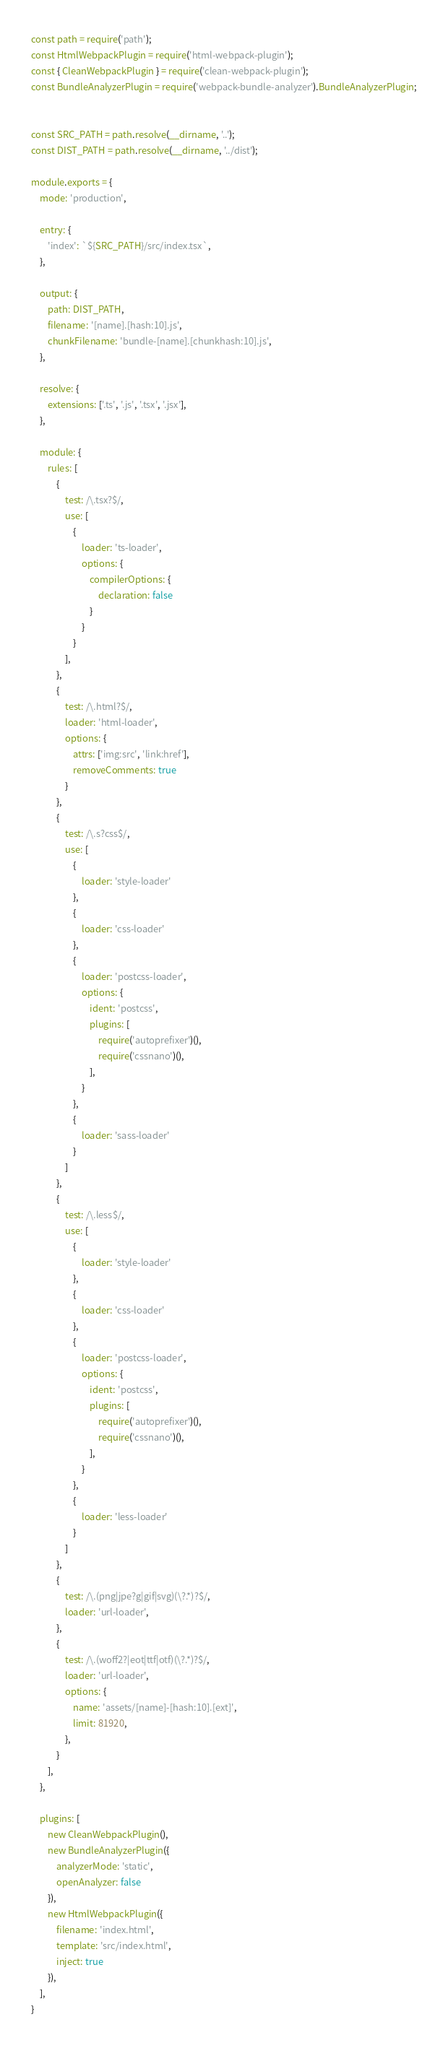<code> <loc_0><loc_0><loc_500><loc_500><_JavaScript_>const path = require('path');
const HtmlWebpackPlugin = require('html-webpack-plugin');
const { CleanWebpackPlugin } = require('clean-webpack-plugin');
const BundleAnalyzerPlugin = require('webpack-bundle-analyzer').BundleAnalyzerPlugin;


const SRC_PATH = path.resolve(__dirname, '..');
const DIST_PATH = path.resolve(__dirname, '../dist');

module.exports = {
    mode: 'production',

    entry: {
        'index': `${SRC_PATH}/src/index.tsx`,
    },

    output: {
        path: DIST_PATH,
        filename: '[name].[hash:10].js',
        chunkFilename: 'bundle-[name].[chunkhash:10].js',
    },

    resolve: {
        extensions: ['.ts', '.js', '.tsx', '.jsx'],
    },

    module: {
        rules: [
            {
                test: /\.tsx?$/,
                use: [
                    {
                        loader: 'ts-loader',
                        options: {
                            compilerOptions: {
                                declaration: false
                            }
                        }
                    }
                ],
            },
            {
                test: /\.html?$/,
                loader: 'html-loader',
                options: {
                    attrs: ['img:src', 'link:href'],
                    removeComments: true
                }
            },
            {
                test: /\.s?css$/,
                use: [
                    {
                        loader: 'style-loader'
                    },
                    {
                        loader: 'css-loader'
                    },
                    {
                        loader: 'postcss-loader',
                        options: {
                            ident: 'postcss',
                            plugins: [
                                require('autoprefixer')(),
                                require('cssnano')(),
                            ],
                        }
                    },
                    {
                        loader: 'sass-loader'
                    }
                ]
            },
            {
                test: /\.less$/,
                use: [
                    {
                        loader: 'style-loader'
                    },
                    {
                        loader: 'css-loader'
                    },
                    {
                        loader: 'postcss-loader',
                        options: {
                            ident: 'postcss',
                            plugins: [
                                require('autoprefixer')(),
                                require('cssnano')(),
                            ],
                        }
                    },
                    {
                        loader: 'less-loader'
                    }
                ]
            },
            {
                test: /\.(png|jpe?g|gif|svg)(\?.*)?$/,
                loader: 'url-loader',
            },
            {
                test: /\.(woff2?|eot|ttf|otf)(\?.*)?$/,
                loader: 'url-loader',
                options: {
                    name: 'assets/[name]-[hash:10].[ext]',
                    limit: 81920,
                },
            }
        ],
    },

    plugins: [
        new CleanWebpackPlugin(),
        new BundleAnalyzerPlugin({
            analyzerMode: 'static',
            openAnalyzer: false
        }),
        new HtmlWebpackPlugin({
            filename: 'index.html',
            template: 'src/index.html',
            inject: true
        }),
    ],
}
</code> 